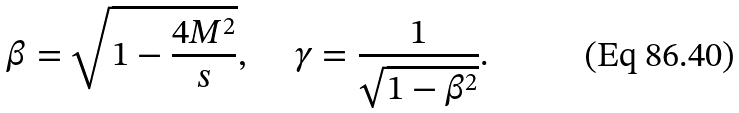Convert formula to latex. <formula><loc_0><loc_0><loc_500><loc_500>\beta = \sqrt { 1 - \frac { 4 M ^ { 2 } } { s } } , \quad \ \gamma = \frac { 1 } { \sqrt { 1 - \beta ^ { 2 } } } .</formula> 